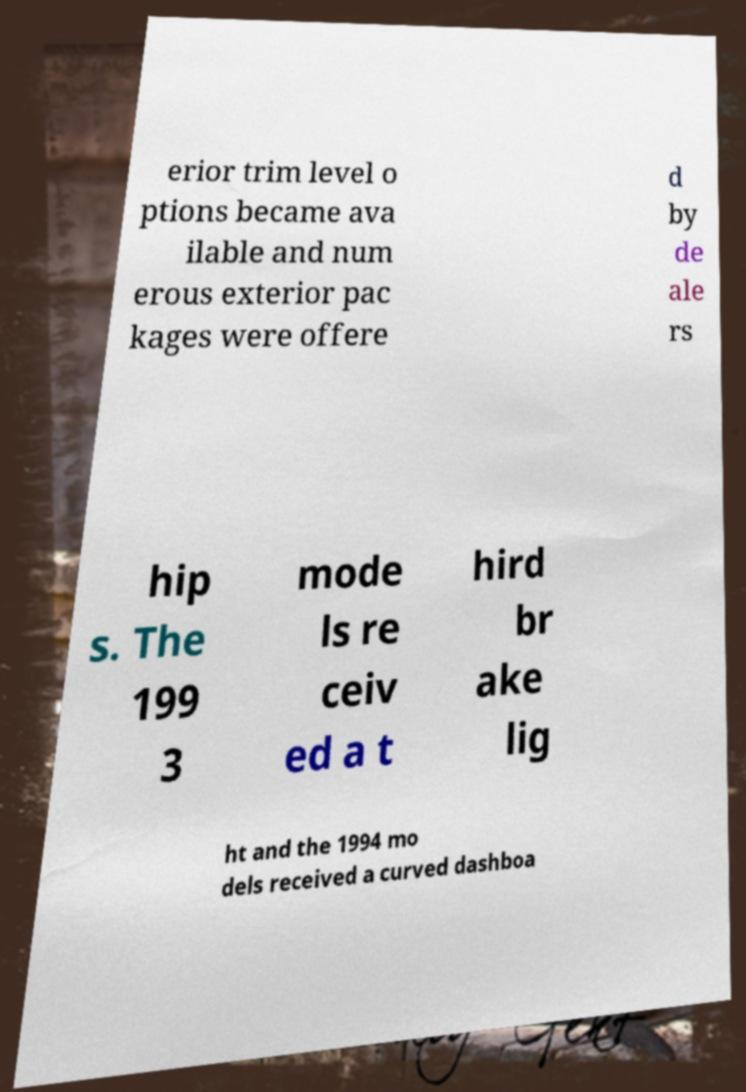Could you extract and type out the text from this image? erior trim level o ptions became ava ilable and num erous exterior pac kages were offere d by de ale rs hip s. The 199 3 mode ls re ceiv ed a t hird br ake lig ht and the 1994 mo dels received a curved dashboa 